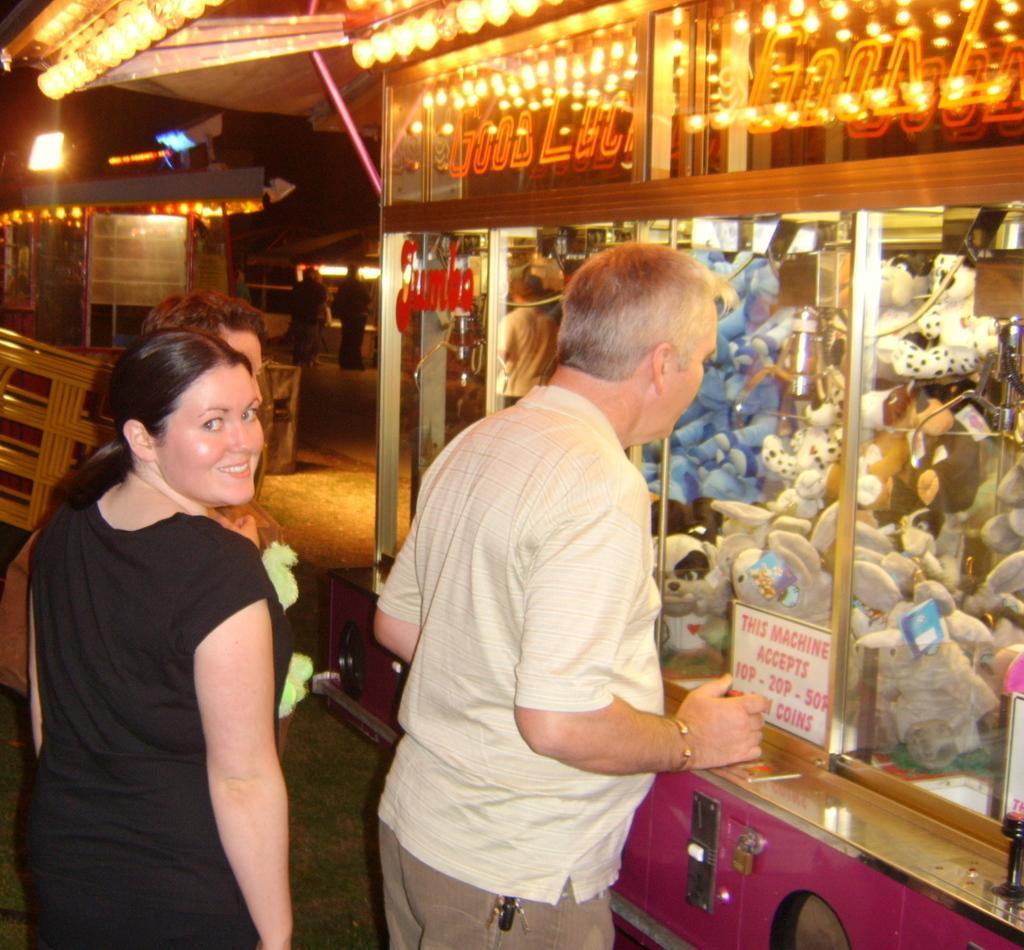Can you describe this image briefly? In this picture there is a woman standing and smiling and there are two persons standing and there are toys behind the glass and there is a board and there is text on the board. At the back there are group of people and there are lights. At the bottom it looks like a grass. 